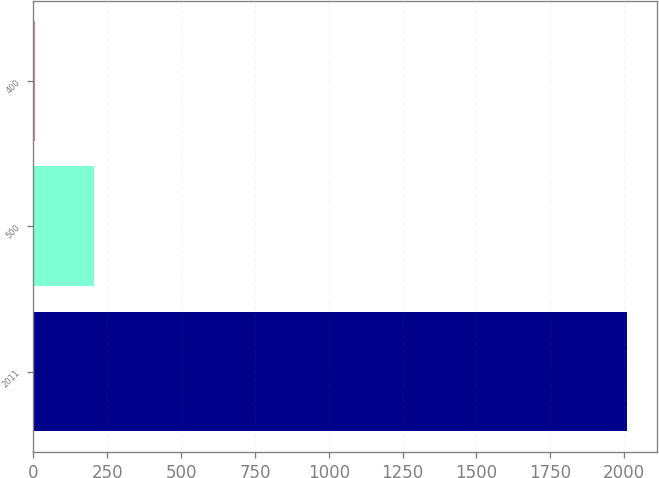<chart> <loc_0><loc_0><loc_500><loc_500><bar_chart><fcel>2011<fcel>500<fcel>400<nl><fcel>2010<fcel>205.42<fcel>4.91<nl></chart> 